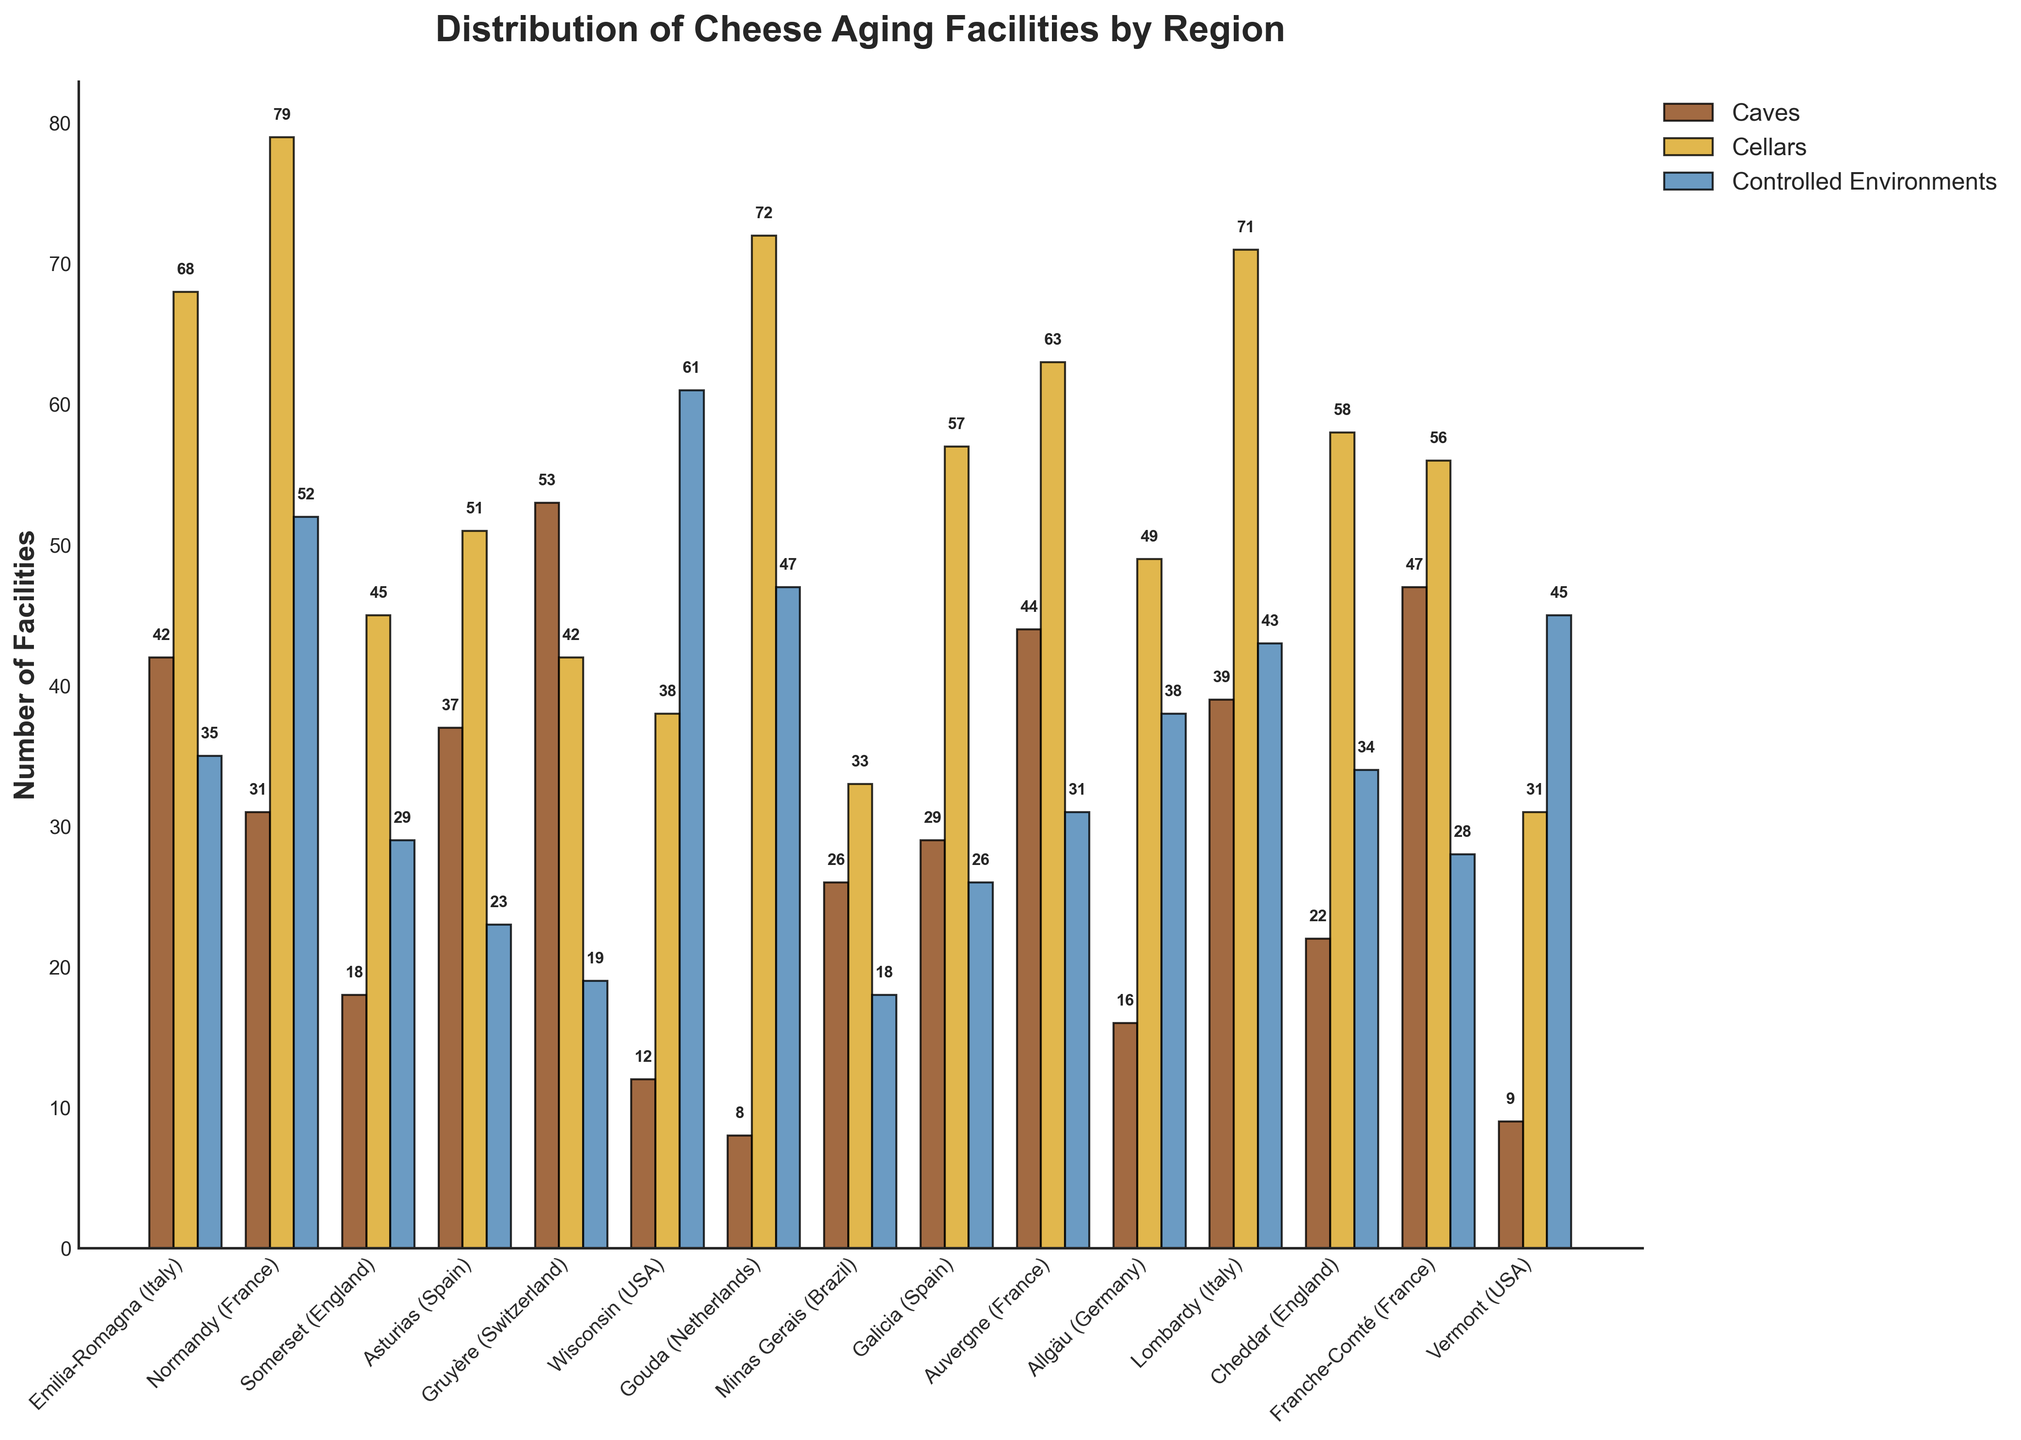What region has the highest number of cave facilities? To find the region with the highest number of cave facilities, look for the tallest bar in the "Caves" category, which is the leftmost bars for each region. The highest value is 53 in Gruyère (Switzerland).
Answer: Gruyère (Switzerland) Which region shows the most balanced distribution across all three types of facilities? To find the most balanced distribution, identify the region where the heights of the bars for all three types (Caves, Cellars, Controlled Environments) are relatively close to each other. In this case, Asturias (Spain) with values (37, 51, 23) appears the most balanced.
Answer: Asturias (Spain) What is the total number of cellars in the regions surveyed? Sum the values for the "Cellars" category: 68 + 79 + 45 + 51 + 42 + 38 + 72 + 33 + 57 + 63 + 49 + 71 + 58 + 56 + 31 = 813.
Answer: 813 Which region has the largest difference between the number of cellars and caves? Calculate the absolute difference between cellars and caves for each region and identify the largest difference: Emilia-Romagna (26), Normandy (48), Somerset (27), Asturias (14), Gruyère (11), Wisconsin (26), Gouda (64), Minas Gerais (7), Galicia (28), Auvergne (19), Allgäu (33), Lombardy (32), Cheddar (36), Franche-Comté (9), Vermont (22). The largest difference is in Gouda (64).
Answer: Gouda (Netherlands) How many more controlled environments are there in Wisconsin compared to cave facilities? Subtract the number of caves from the number of controlled environments in Wisconsin: 61 - 12 = 49.
Answer: 49 Which region has the lowest number of controlled environment facilities? Identify the shortest bar in the "Controlled Environments" section, which is 18 in both Gruyère (Switzerland) and Minas Gerais (Brazil).
Answer: Gruyère (Switzerland) and Minas Gerais (Brazil) What is the average number of cheese aging facilities per region for caves? Add the values of caves and divide by the number of regions: (42 + 31 + 18 + 37 + 53 + 12 + 8 + 26 + 29 + 44 + 16 + 39 + 22 + 47 + 9) / 15 = 433 / 15 = 28.87.
Answer: 28.87 Compare the number of cellars in Emilia-Romagna and Lombardy. Which one is greater and by how much? Subtract the number of cellars in Emilia-Romagna from Lombardy: 71 - 68 = 3.
Answer: Lombardy by 3 How many total controlled environment facilities are there in all the regions combined? Sum the values for controlled environments: 35 + 52 + 29 + 23 + 19 + 61 + 47 + 18 + 26 + 31 + 38 + 43 + 34 + 28 + 45 = 529.
Answer: 529 In which region do caves represent the highest proportion of all cheese aging facilities? Calculate the proportion of caves in each region and determine the highest:
- Emilia-Romagna: 42/(42+68+35) = 0.28
- Normandy: 31/(31+79+52) = 0.18
- Somerset: 18/(18+45+29) = 0.19
- Asturias: 37/(37+51+23) = 0.33
- Gruyère: 53/(53+42+19) = 0.44
- Wisconsin: 12/(12+38+61) = 0.11
- Gouda: 8/(8+72+47) = 0.06
- Minas Gerais: 26/(26+33+18) = 0.35
- Galicia: 29/(29+57+26) = 0.27
- Auvergne: 44/(44+63+31) = 0.32
- Allgäu: 16/(16+49+38) = 0.16
- Lombardy: 39/(39+71+43) = 0.26
- Cheddar: 22/(22+58+34) = 0.20
- Franche-Comté: 47/(47+56+28) = 0.35
- Vermont: 9/(9+31+45) = 0.11. The highest proportion is in Gruyère with 0.44.
Answer: Gruyère (Switzerland) 